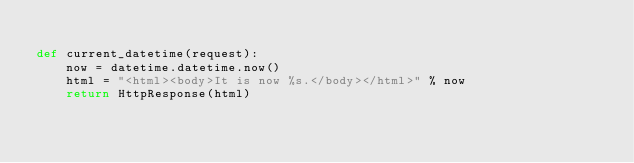Convert code to text. <code><loc_0><loc_0><loc_500><loc_500><_Python_>
def current_datetime(request):
    now = datetime.datetime.now()
    html = "<html><body>It is now %s.</body></html>" % now
    return HttpResponse(html)
</code> 